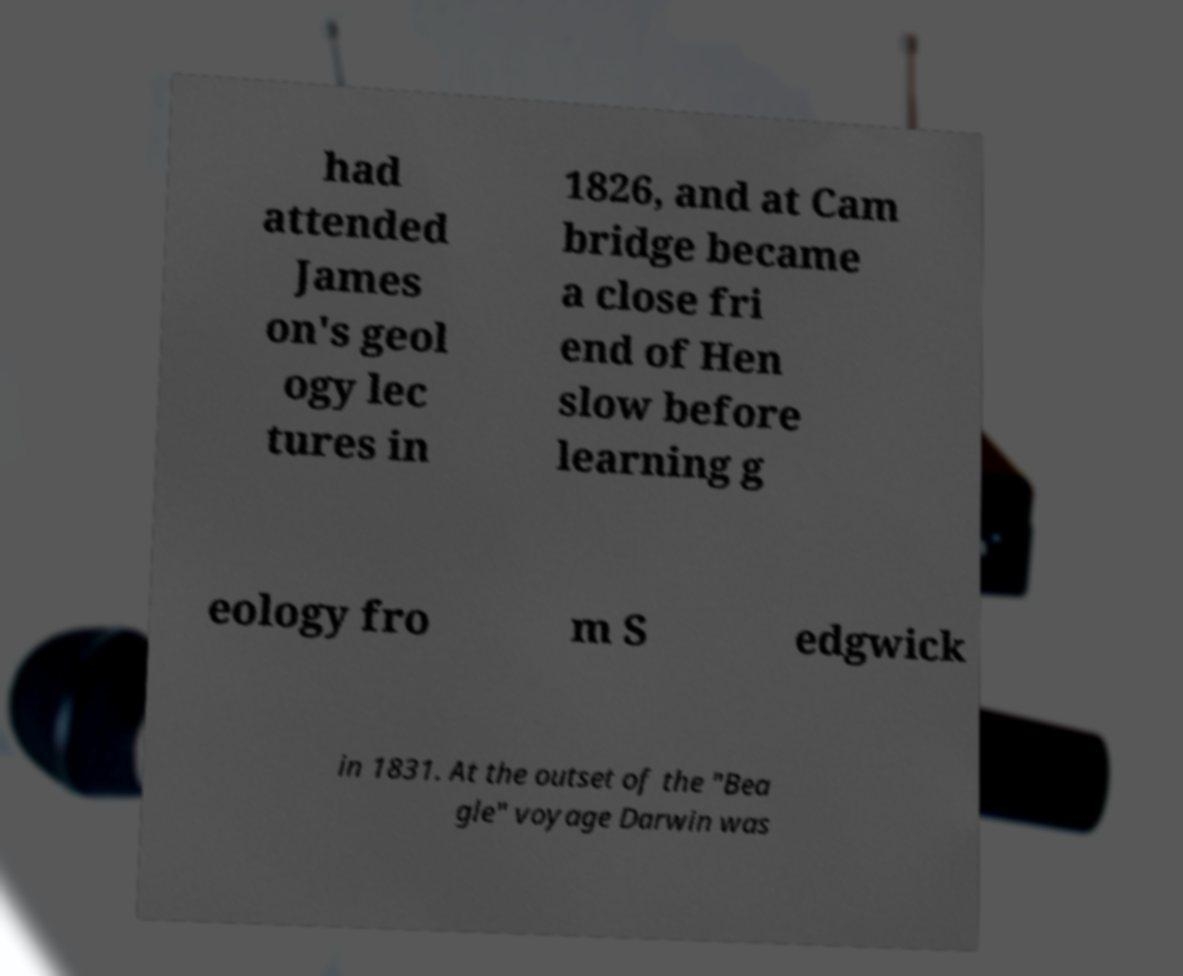Could you assist in decoding the text presented in this image and type it out clearly? had attended James on's geol ogy lec tures in 1826, and at Cam bridge became a close fri end of Hen slow before learning g eology fro m S edgwick in 1831. At the outset of the "Bea gle" voyage Darwin was 